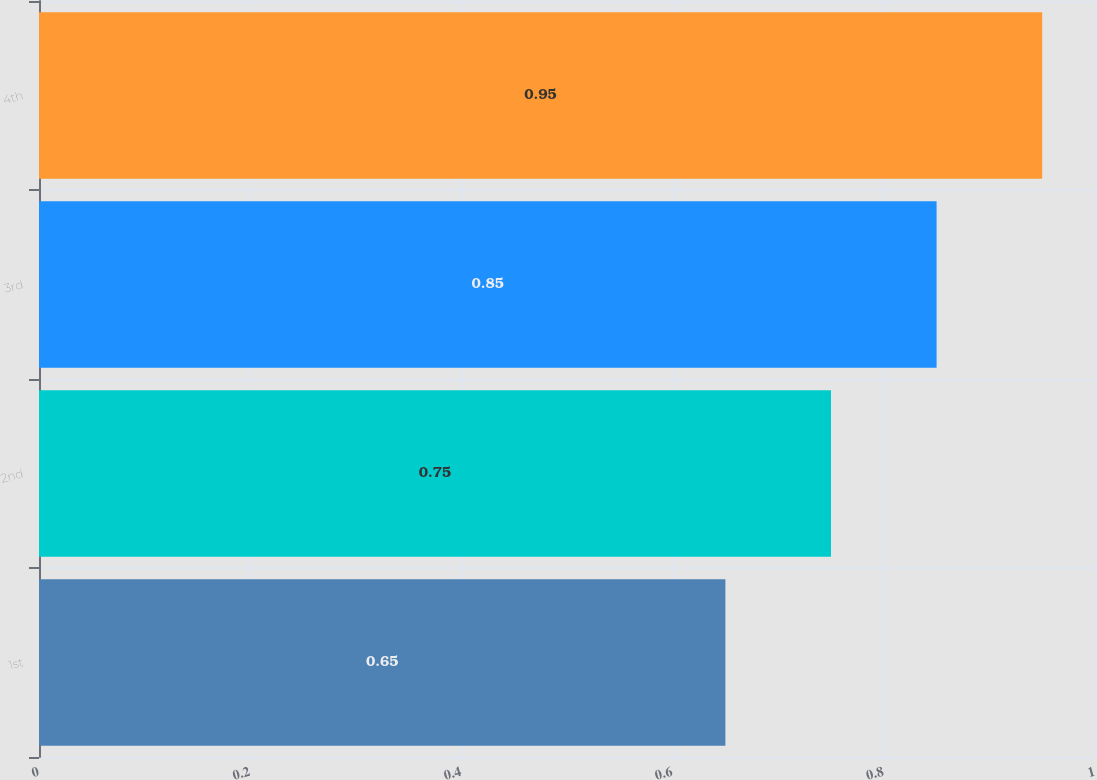<chart> <loc_0><loc_0><loc_500><loc_500><bar_chart><fcel>1st<fcel>2nd<fcel>3rd<fcel>4th<nl><fcel>0.65<fcel>0.75<fcel>0.85<fcel>0.95<nl></chart> 